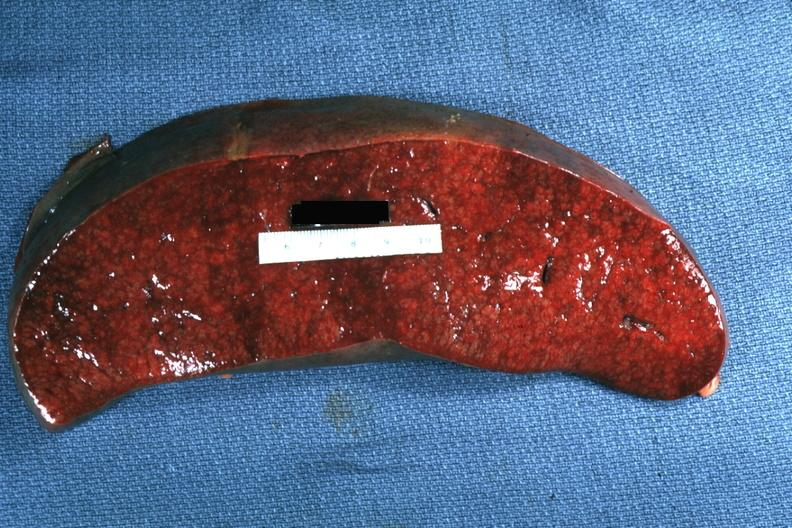s pierre robin sndrome present?
Answer the question using a single word or phrase. No 